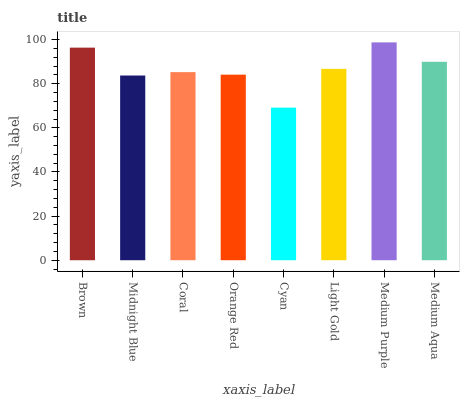Is Cyan the minimum?
Answer yes or no. Yes. Is Medium Purple the maximum?
Answer yes or no. Yes. Is Midnight Blue the minimum?
Answer yes or no. No. Is Midnight Blue the maximum?
Answer yes or no. No. Is Brown greater than Midnight Blue?
Answer yes or no. Yes. Is Midnight Blue less than Brown?
Answer yes or no. Yes. Is Midnight Blue greater than Brown?
Answer yes or no. No. Is Brown less than Midnight Blue?
Answer yes or no. No. Is Light Gold the high median?
Answer yes or no. Yes. Is Coral the low median?
Answer yes or no. Yes. Is Brown the high median?
Answer yes or no. No. Is Brown the low median?
Answer yes or no. No. 